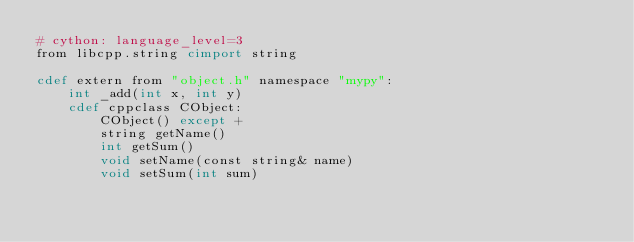Convert code to text. <code><loc_0><loc_0><loc_500><loc_500><_Cython_># cython: language_level=3
from libcpp.string cimport string

cdef extern from "object.h" namespace "mypy":
    int _add(int x, int y)
    cdef cppclass CObject:
        CObject() except +
        string getName()
        int getSum()
        void setName(const string& name)
        void setSum(int sum)
</code> 